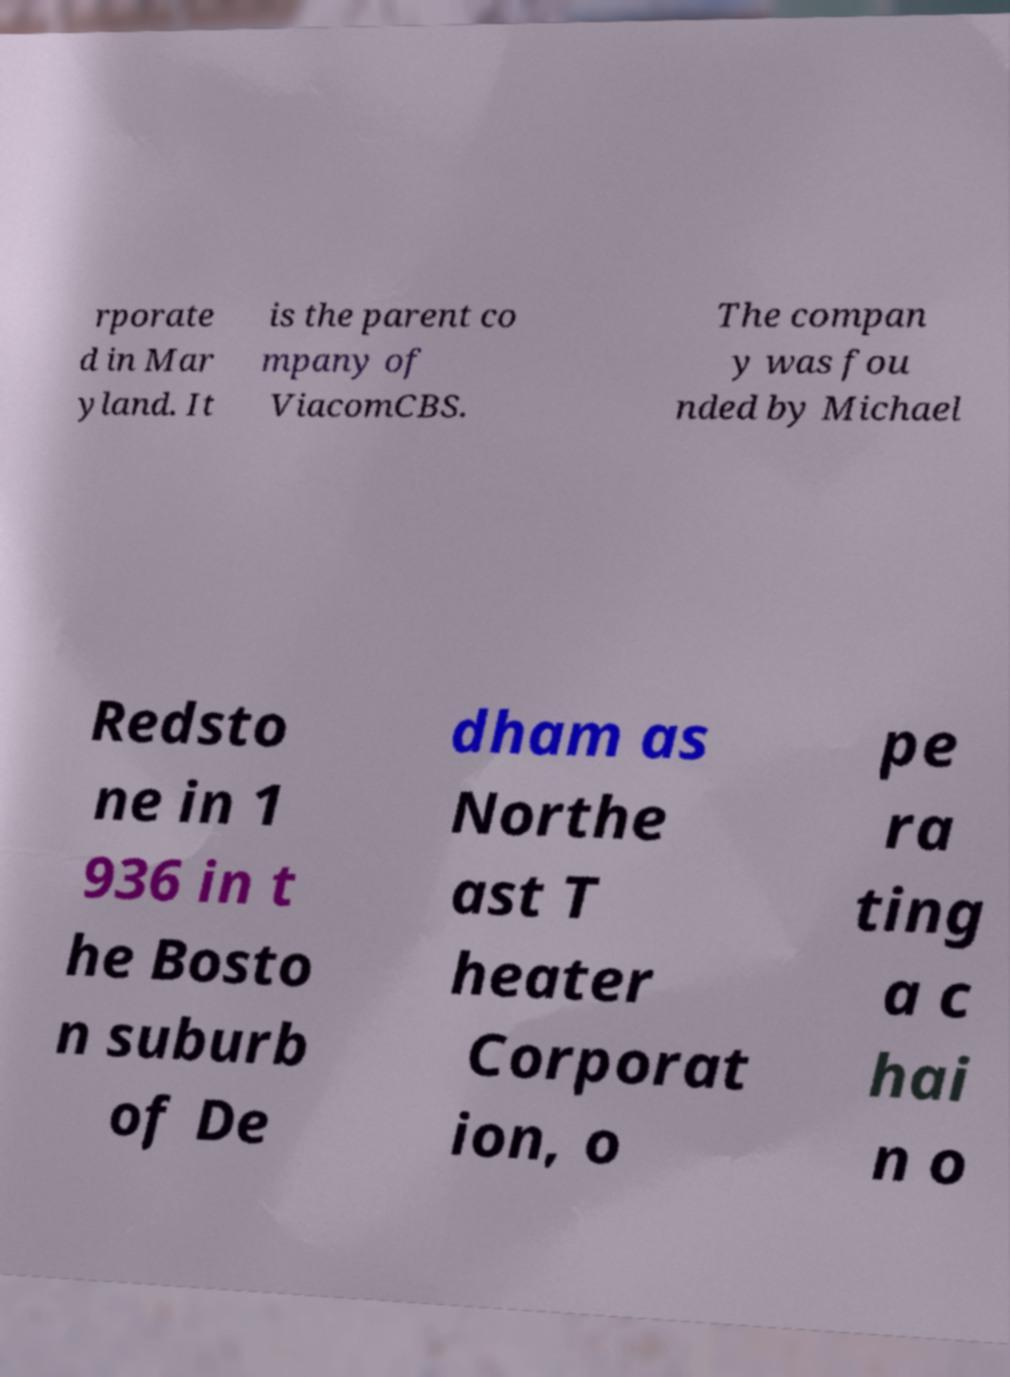Can you accurately transcribe the text from the provided image for me? rporate d in Mar yland. It is the parent co mpany of ViacomCBS. The compan y was fou nded by Michael Redsto ne in 1 936 in t he Bosto n suburb of De dham as Northe ast T heater Corporat ion, o pe ra ting a c hai n o 